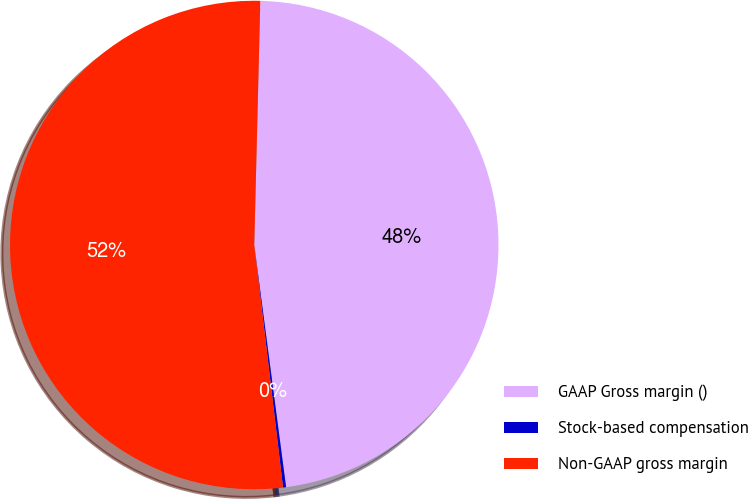Convert chart. <chart><loc_0><loc_0><loc_500><loc_500><pie_chart><fcel>GAAP Gross margin ()<fcel>Stock-based compensation<fcel>Non-GAAP gross margin<nl><fcel>47.53%<fcel>0.2%<fcel>52.28%<nl></chart> 